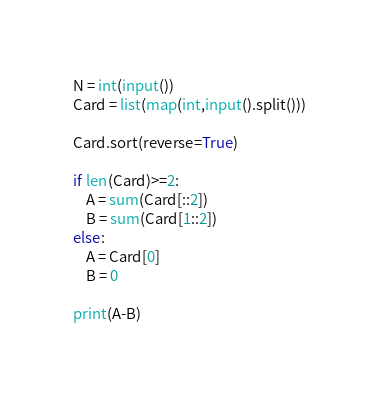<code> <loc_0><loc_0><loc_500><loc_500><_Python_>N = int(input())
Card = list(map(int,input().split()))

Card.sort(reverse=True)

if len(Card)>=2:
    A = sum(Card[::2])
    B = sum(Card[1::2])
else:
    A = Card[0]
    B = 0

print(A-B)</code> 